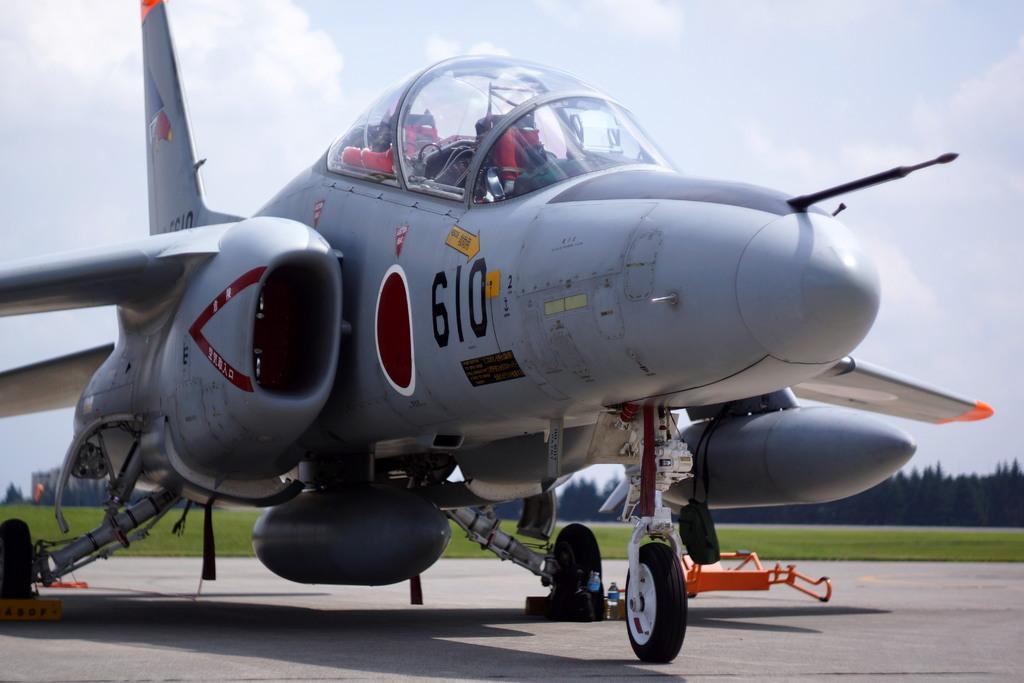Can you describe this image briefly? There is an aircraft in the foreground, there is an object at the bottom side and there are trees, grassland and sky in the background area. 